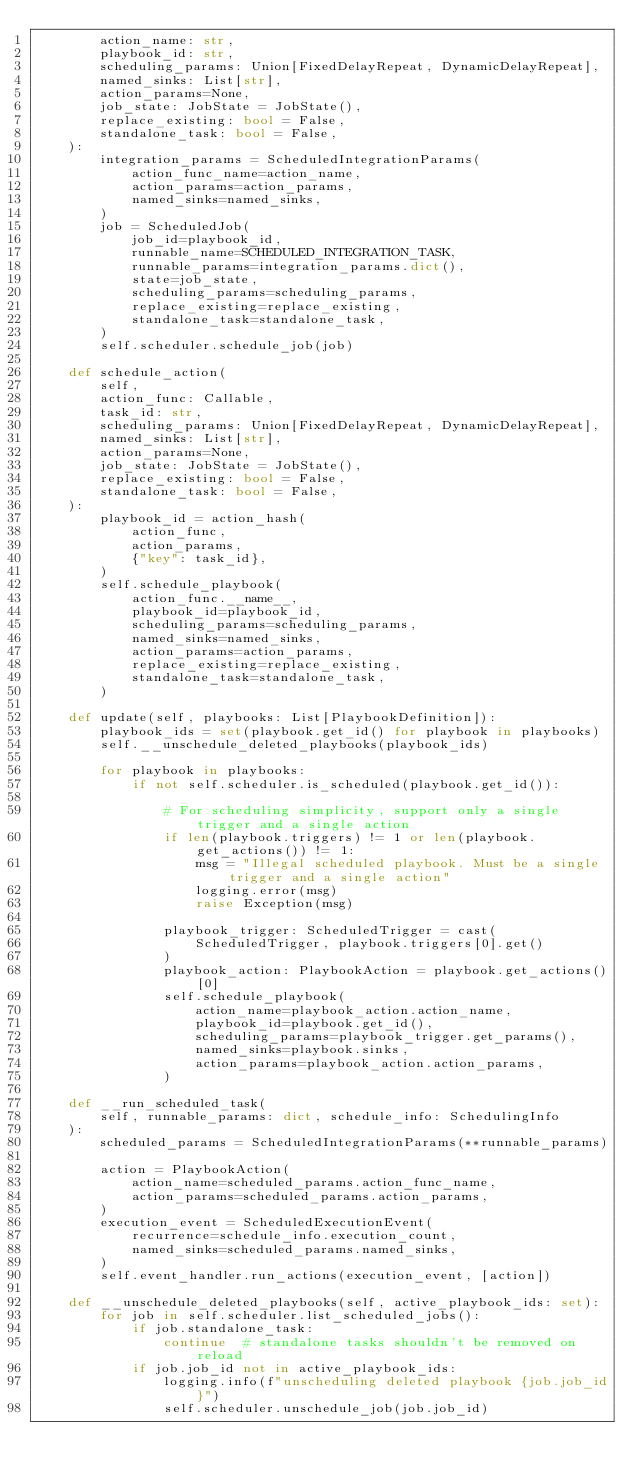Convert code to text. <code><loc_0><loc_0><loc_500><loc_500><_Python_>        action_name: str,
        playbook_id: str,
        scheduling_params: Union[FixedDelayRepeat, DynamicDelayRepeat],
        named_sinks: List[str],
        action_params=None,
        job_state: JobState = JobState(),
        replace_existing: bool = False,
        standalone_task: bool = False,
    ):
        integration_params = ScheduledIntegrationParams(
            action_func_name=action_name,
            action_params=action_params,
            named_sinks=named_sinks,
        )
        job = ScheduledJob(
            job_id=playbook_id,
            runnable_name=SCHEDULED_INTEGRATION_TASK,
            runnable_params=integration_params.dict(),
            state=job_state,
            scheduling_params=scheduling_params,
            replace_existing=replace_existing,
            standalone_task=standalone_task,
        )
        self.scheduler.schedule_job(job)

    def schedule_action(
        self,
        action_func: Callable,
        task_id: str,
        scheduling_params: Union[FixedDelayRepeat, DynamicDelayRepeat],
        named_sinks: List[str],
        action_params=None,
        job_state: JobState = JobState(),
        replace_existing: bool = False,
        standalone_task: bool = False,
    ):
        playbook_id = action_hash(
            action_func,
            action_params,
            {"key": task_id},
        )
        self.schedule_playbook(
            action_func.__name__,
            playbook_id=playbook_id,
            scheduling_params=scheduling_params,
            named_sinks=named_sinks,
            action_params=action_params,
            replace_existing=replace_existing,
            standalone_task=standalone_task,
        )

    def update(self, playbooks: List[PlaybookDefinition]):
        playbook_ids = set(playbook.get_id() for playbook in playbooks)
        self.__unschedule_deleted_playbooks(playbook_ids)

        for playbook in playbooks:
            if not self.scheduler.is_scheduled(playbook.get_id()):

                # For scheduling simplicity, support only a single trigger and a single action
                if len(playbook.triggers) != 1 or len(playbook.get_actions()) != 1:
                    msg = "Illegal scheduled playbook. Must be a single trigger and a single action"
                    logging.error(msg)
                    raise Exception(msg)

                playbook_trigger: ScheduledTrigger = cast(
                    ScheduledTrigger, playbook.triggers[0].get()
                )
                playbook_action: PlaybookAction = playbook.get_actions()[0]
                self.schedule_playbook(
                    action_name=playbook_action.action_name,
                    playbook_id=playbook.get_id(),
                    scheduling_params=playbook_trigger.get_params(),
                    named_sinks=playbook.sinks,
                    action_params=playbook_action.action_params,
                )

    def __run_scheduled_task(
        self, runnable_params: dict, schedule_info: SchedulingInfo
    ):
        scheduled_params = ScheduledIntegrationParams(**runnable_params)

        action = PlaybookAction(
            action_name=scheduled_params.action_func_name,
            action_params=scheduled_params.action_params,
        )
        execution_event = ScheduledExecutionEvent(
            recurrence=schedule_info.execution_count,
            named_sinks=scheduled_params.named_sinks,
        )
        self.event_handler.run_actions(execution_event, [action])

    def __unschedule_deleted_playbooks(self, active_playbook_ids: set):
        for job in self.scheduler.list_scheduled_jobs():
            if job.standalone_task:
                continue  # standalone tasks shouldn't be removed on reload
            if job.job_id not in active_playbook_ids:
                logging.info(f"unscheduling deleted playbook {job.job_id}")
                self.scheduler.unschedule_job(job.job_id)
</code> 